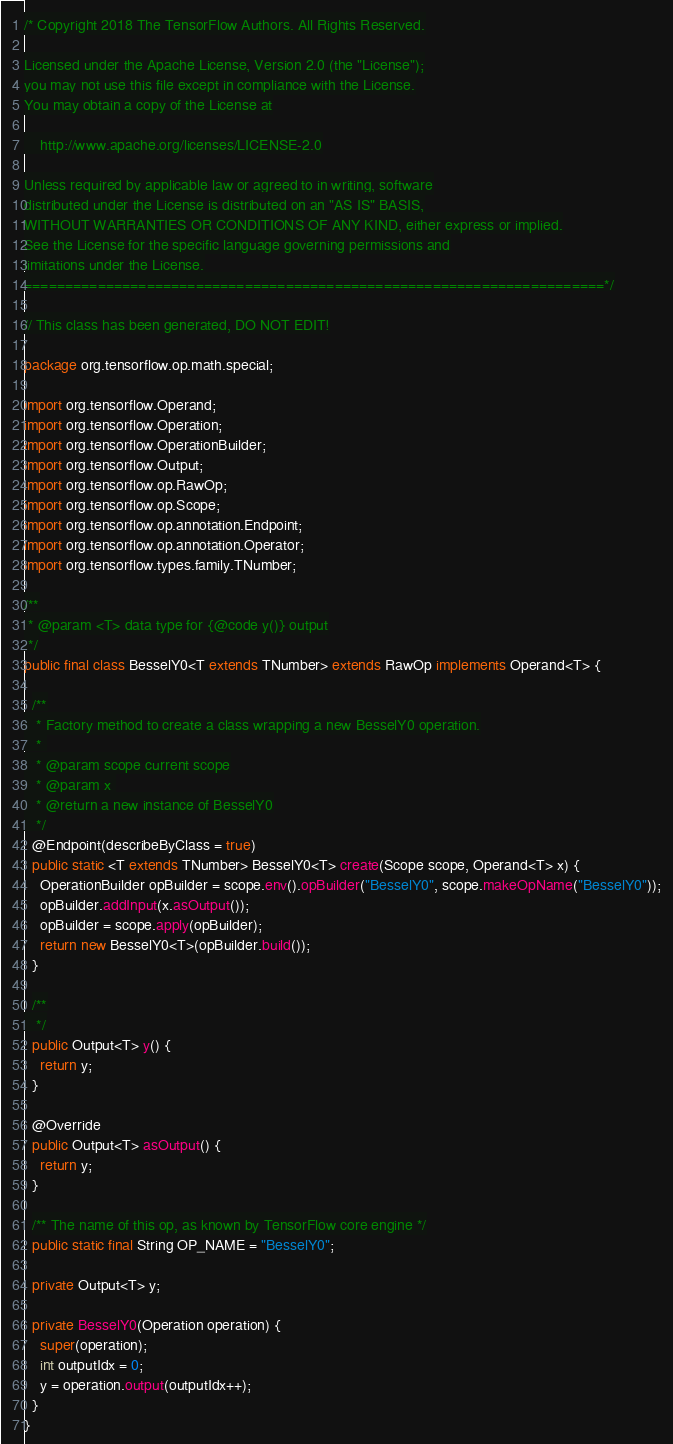<code> <loc_0><loc_0><loc_500><loc_500><_Java_>/* Copyright 2018 The TensorFlow Authors. All Rights Reserved.

Licensed under the Apache License, Version 2.0 (the "License");
you may not use this file except in compliance with the License.
You may obtain a copy of the License at

    http://www.apache.org/licenses/LICENSE-2.0

Unless required by applicable law or agreed to in writing, software
distributed under the License is distributed on an "AS IS" BASIS,
WITHOUT WARRANTIES OR CONDITIONS OF ANY KIND, either express or implied.
See the License for the specific language governing permissions and
limitations under the License.
=======================================================================*/

// This class has been generated, DO NOT EDIT!

package org.tensorflow.op.math.special;

import org.tensorflow.Operand;
import org.tensorflow.Operation;
import org.tensorflow.OperationBuilder;
import org.tensorflow.Output;
import org.tensorflow.op.RawOp;
import org.tensorflow.op.Scope;
import org.tensorflow.op.annotation.Endpoint;
import org.tensorflow.op.annotation.Operator;
import org.tensorflow.types.family.TNumber;

/**
 * @param <T> data type for {@code y()} output
 */
public final class BesselY0<T extends TNumber> extends RawOp implements Operand<T> {
  
  /**
   * Factory method to create a class wrapping a new BesselY0 operation.
   * 
   * @param scope current scope
   * @param x 
   * @return a new instance of BesselY0
   */
  @Endpoint(describeByClass = true)
  public static <T extends TNumber> BesselY0<T> create(Scope scope, Operand<T> x) {
    OperationBuilder opBuilder = scope.env().opBuilder("BesselY0", scope.makeOpName("BesselY0"));
    opBuilder.addInput(x.asOutput());
    opBuilder = scope.apply(opBuilder);
    return new BesselY0<T>(opBuilder.build());
  }
  
  /**
   */
  public Output<T> y() {
    return y;
  }
  
  @Override
  public Output<T> asOutput() {
    return y;
  }
  
  /** The name of this op, as known by TensorFlow core engine */
  public static final String OP_NAME = "BesselY0";
  
  private Output<T> y;
  
  private BesselY0(Operation operation) {
    super(operation);
    int outputIdx = 0;
    y = operation.output(outputIdx++);
  }
}
</code> 